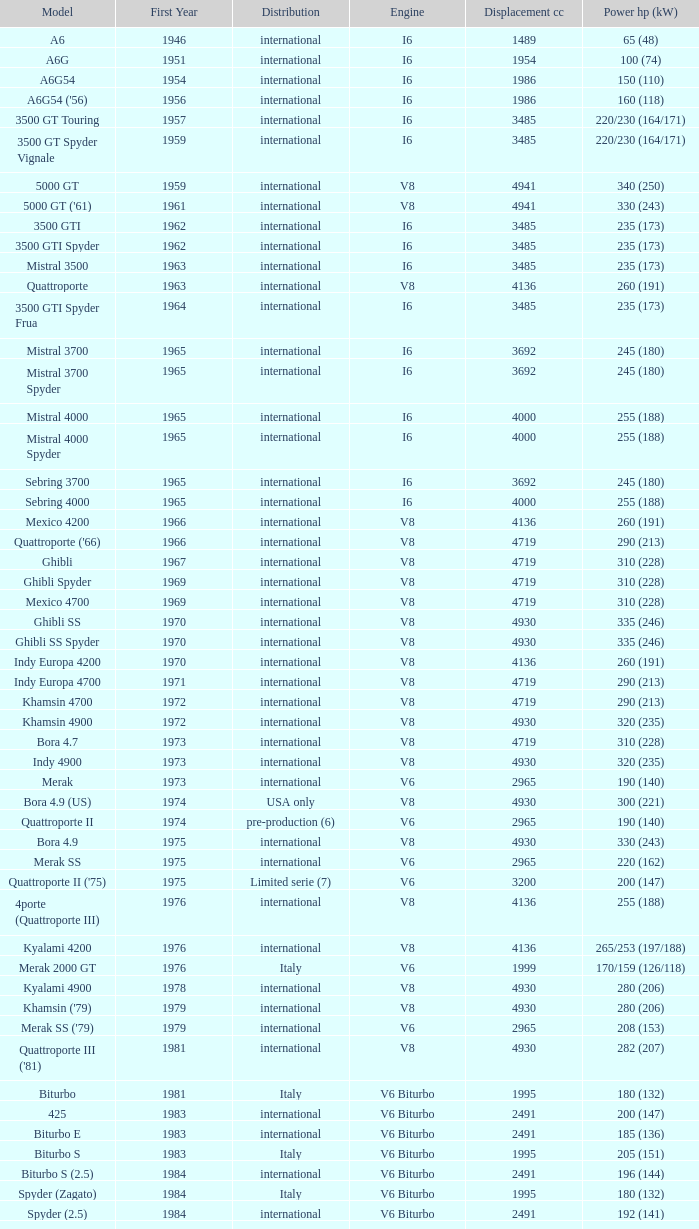What is the total number of First Year, when Displacement CC is greater than 4719, when Engine is V8, when Power HP (kW) is "335 (246)", and when Model is "Ghibli SS"? 1.0. 